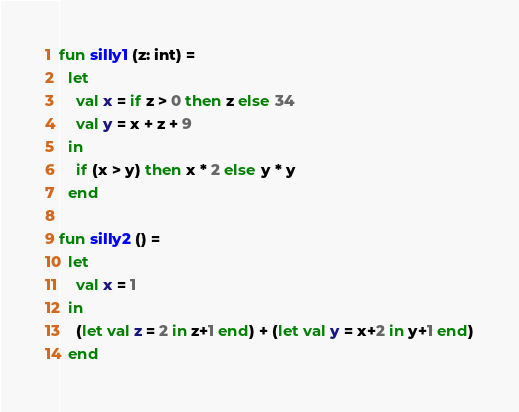Convert code to text. <code><loc_0><loc_0><loc_500><loc_500><_SML_>fun silly1 (z: int) =
  let
    val x = if z > 0 then z else 34
    val y = x + z + 9
  in
    if (x > y) then x * 2 else y * y
  end

fun silly2 () =
  let
    val x = 1
  in
    (let val z = 2 in z+1 end) + (let val y = x+2 in y+1 end)
  end
</code> 